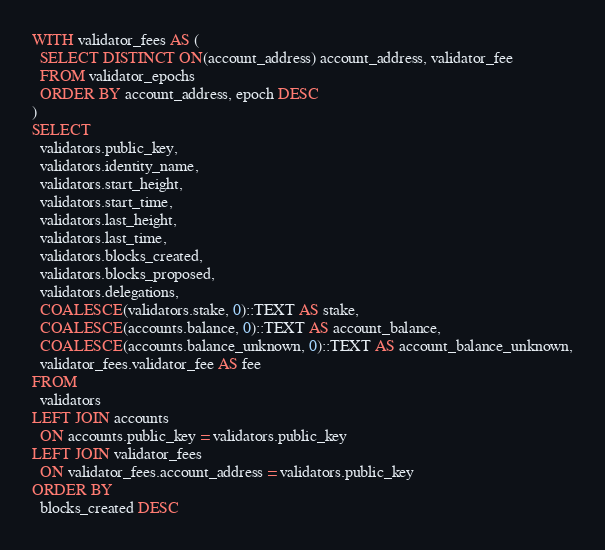<code> <loc_0><loc_0><loc_500><loc_500><_SQL_>WITH validator_fees AS (
  SELECT DISTINCT ON(account_address) account_address, validator_fee
  FROM validator_epochs
  ORDER BY account_address, epoch DESC
)
SELECT
  validators.public_key,
  validators.identity_name,
  validators.start_height,
  validators.start_time,
  validators.last_height,
  validators.last_time,
  validators.blocks_created,
  validators.blocks_proposed,
  validators.delegations,
  COALESCE(validators.stake, 0)::TEXT AS stake,
  COALESCE(accounts.balance, 0)::TEXT AS account_balance,
  COALESCE(accounts.balance_unknown, 0)::TEXT AS account_balance_unknown,
  validator_fees.validator_fee AS fee
FROM
  validators
LEFT JOIN accounts
  ON accounts.public_key = validators.public_key
LEFT JOIN validator_fees
  ON validator_fees.account_address = validators.public_key
ORDER BY
  blocks_created DESC
</code> 